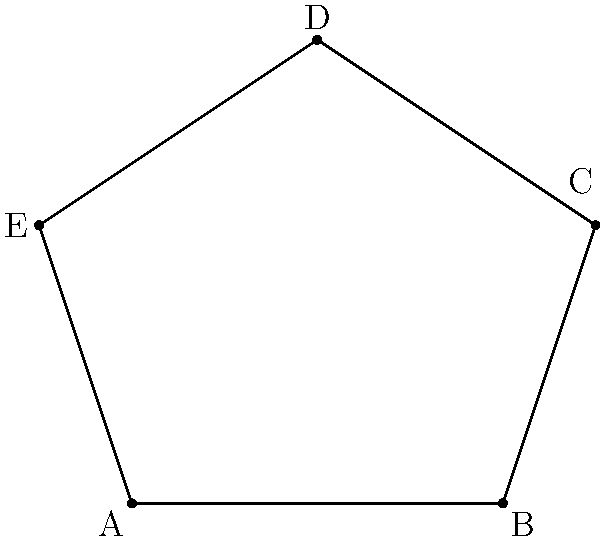As a city guide, you're explaining the unique architecture of a pentagonal historic building to tourists. The floor plan of this building is shown above. If you know that the measure of angle B is 108°, what is the sum of the measures of angles A and E? Let's approach this step-by-step:

1) In any pentagon, the sum of all interior angles is $(5-2) \times 180° = 540°$.

2) We're given that angle B is 108°.

3) In a pentagon, all angles would be equal if it were regular. In a regular pentagon, each angle would measure $\frac{540°}{5} = 108°$.

4) Since we're told angle B is 108°, and this is the measure of an angle in a regular pentagon, we can deduce that this is likely a regular pentagon.

5) In a regular pentagon, all angles are equal. So each angle (A, B, C, D, and E) measures 108°.

6) Therefore, the sum of angles A and E is $108° + 108° = 216°$.

This explanation provides insight into the geometric properties of regular pentagons, which could be interesting for tourists learning about the building's unique architecture.
Answer: 216° 